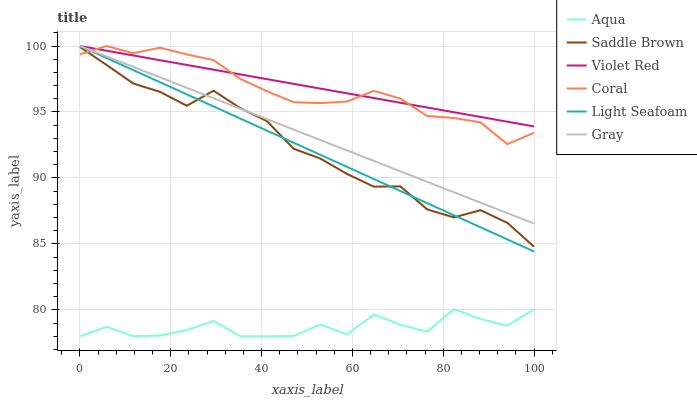Does Aqua have the minimum area under the curve?
Answer yes or no. Yes. Does Violet Red have the maximum area under the curve?
Answer yes or no. Yes. Does Coral have the minimum area under the curve?
Answer yes or no. No. Does Coral have the maximum area under the curve?
Answer yes or no. No. Is Violet Red the smoothest?
Answer yes or no. Yes. Is Aqua the roughest?
Answer yes or no. Yes. Is Coral the smoothest?
Answer yes or no. No. Is Coral the roughest?
Answer yes or no. No. Does Aqua have the lowest value?
Answer yes or no. Yes. Does Coral have the lowest value?
Answer yes or no. No. Does Light Seafoam have the highest value?
Answer yes or no. Yes. Does Aqua have the highest value?
Answer yes or no. No. Is Aqua less than Light Seafoam?
Answer yes or no. Yes. Is Gray greater than Aqua?
Answer yes or no. Yes. Does Gray intersect Saddle Brown?
Answer yes or no. Yes. Is Gray less than Saddle Brown?
Answer yes or no. No. Is Gray greater than Saddle Brown?
Answer yes or no. No. Does Aqua intersect Light Seafoam?
Answer yes or no. No. 